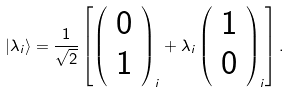<formula> <loc_0><loc_0><loc_500><loc_500>| \lambda _ { i } \rangle = \frac { 1 } { \sqrt { 2 } } \left [ \left ( \begin{array} { c } 0 \\ 1 \end{array} \right ) _ { i } + \lambda _ { i } \left ( \begin{array} { c } 1 \\ 0 \end{array} \right ) _ { i } \right ] .</formula> 